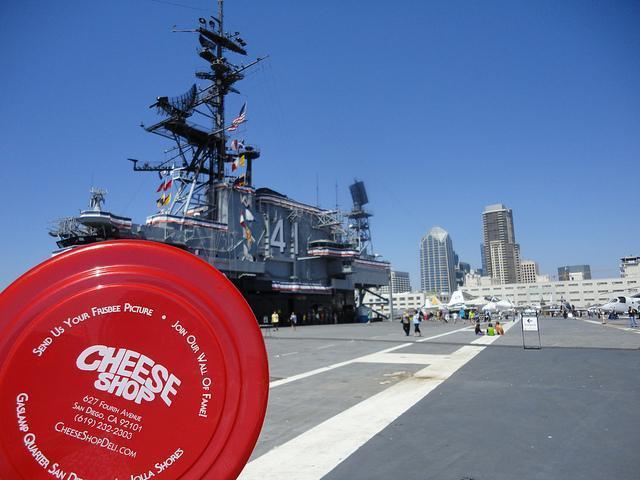How many people can be seen?
Give a very brief answer. 1. How many cares are to the left of the bike rider?
Give a very brief answer. 0. 